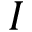<formula> <loc_0><loc_0><loc_500><loc_500>I</formula> 